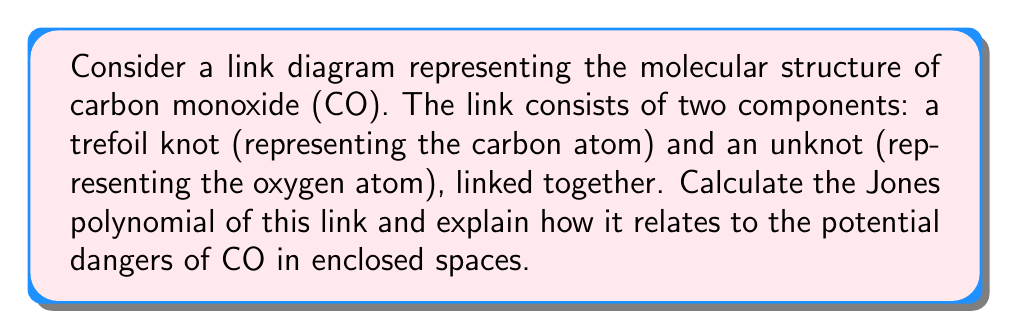Teach me how to tackle this problem. Let's approach this step-by-step:

1) First, we need to identify the link. We have a trefoil knot linked with an unknot. Let's call this link L.

2) The Jones polynomial of a link is calculated using the skein relation:

   $$t^{-1}V(L_+) - tV(L_-) = (t^{1/2} - t^{-1/2})V(L_0)$$

   where $L_+$, $L_-$, and $L_0$ are links that are identical except at one crossing.

3) For our link L, we can start by considering the trefoil component. The Jones polynomial of a trefoil knot is:

   $$V(\text{trefoil}) = t + t^3 - t^4$$

4) The Jones polynomial of an unknot is simply 1:

   $$V(\text{unknot}) = 1$$

5) When we link these components, we introduce additional crossings. Assuming the simplest possible linking (with one crossing between the trefoil and the unknot), we can use the multiplication property of Jones polynomials:

   $$V(L) = (t^{1/2} - t^{-1/2}) \cdot V(\text{trefoil}) \cdot V(\text{unknot})$$

6) Substituting the values:

   $$V(L) = (t^{1/2} - t^{-1/2}) \cdot (t + t^3 - t^4) \cdot 1$$

7) Simplifying:

   $$V(L) = t^{3/2} + t^{7/2} - t^{9/2} - t^{1/2} - t^{5/2} + t^{7/2}$$

8) Collecting like terms:

   $$V(L) = -t^{1/2} + t^{3/2} - t^{5/2} + 2t^{7/2} - t^{9/2}$$

This Jones polynomial uniquely identifies our CO link. The complexity of this polynomial reflects the intricate bonding in CO molecules, which contributes to their stability and potential danger in enclosed spaces. The presence of both positive and negative terms in the polynomial could be interpreted as representing the dual nature of CO - essential for life in some contexts, but potentially lethal in others, emphasizing the importance of proper ventilation and CO detectors.
Answer: $V(L) = -t^{1/2} + t^{3/2} - t^{5/2} + 2t^{7/2} - t^{9/2}$ 